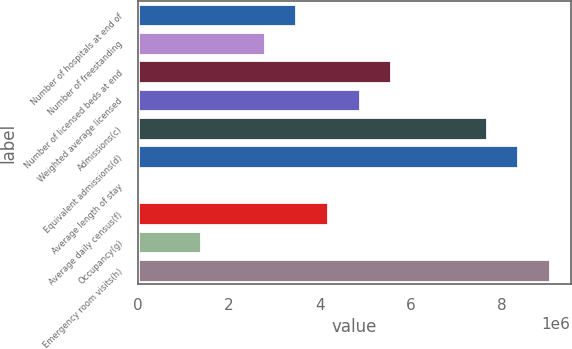Convert chart. <chart><loc_0><loc_0><loc_500><loc_500><bar_chart><fcel>Number of hospitals at end of<fcel>Number of freestanding<fcel>Number of licensed beds at end<fcel>Weighted average licensed<fcel>Admissions(c)<fcel>Equivalent admissions(d)<fcel>Average length of stay<fcel>Average daily census(f)<fcel>Occupancy(g)<fcel>Emergency room visits(h)<nl><fcel>3.48406e+06<fcel>2.78725e+06<fcel>5.57449e+06<fcel>4.87768e+06<fcel>7.66493e+06<fcel>8.36174e+06<fcel>4.8<fcel>4.18087e+06<fcel>1.39363e+06<fcel>9.05855e+06<nl></chart> 